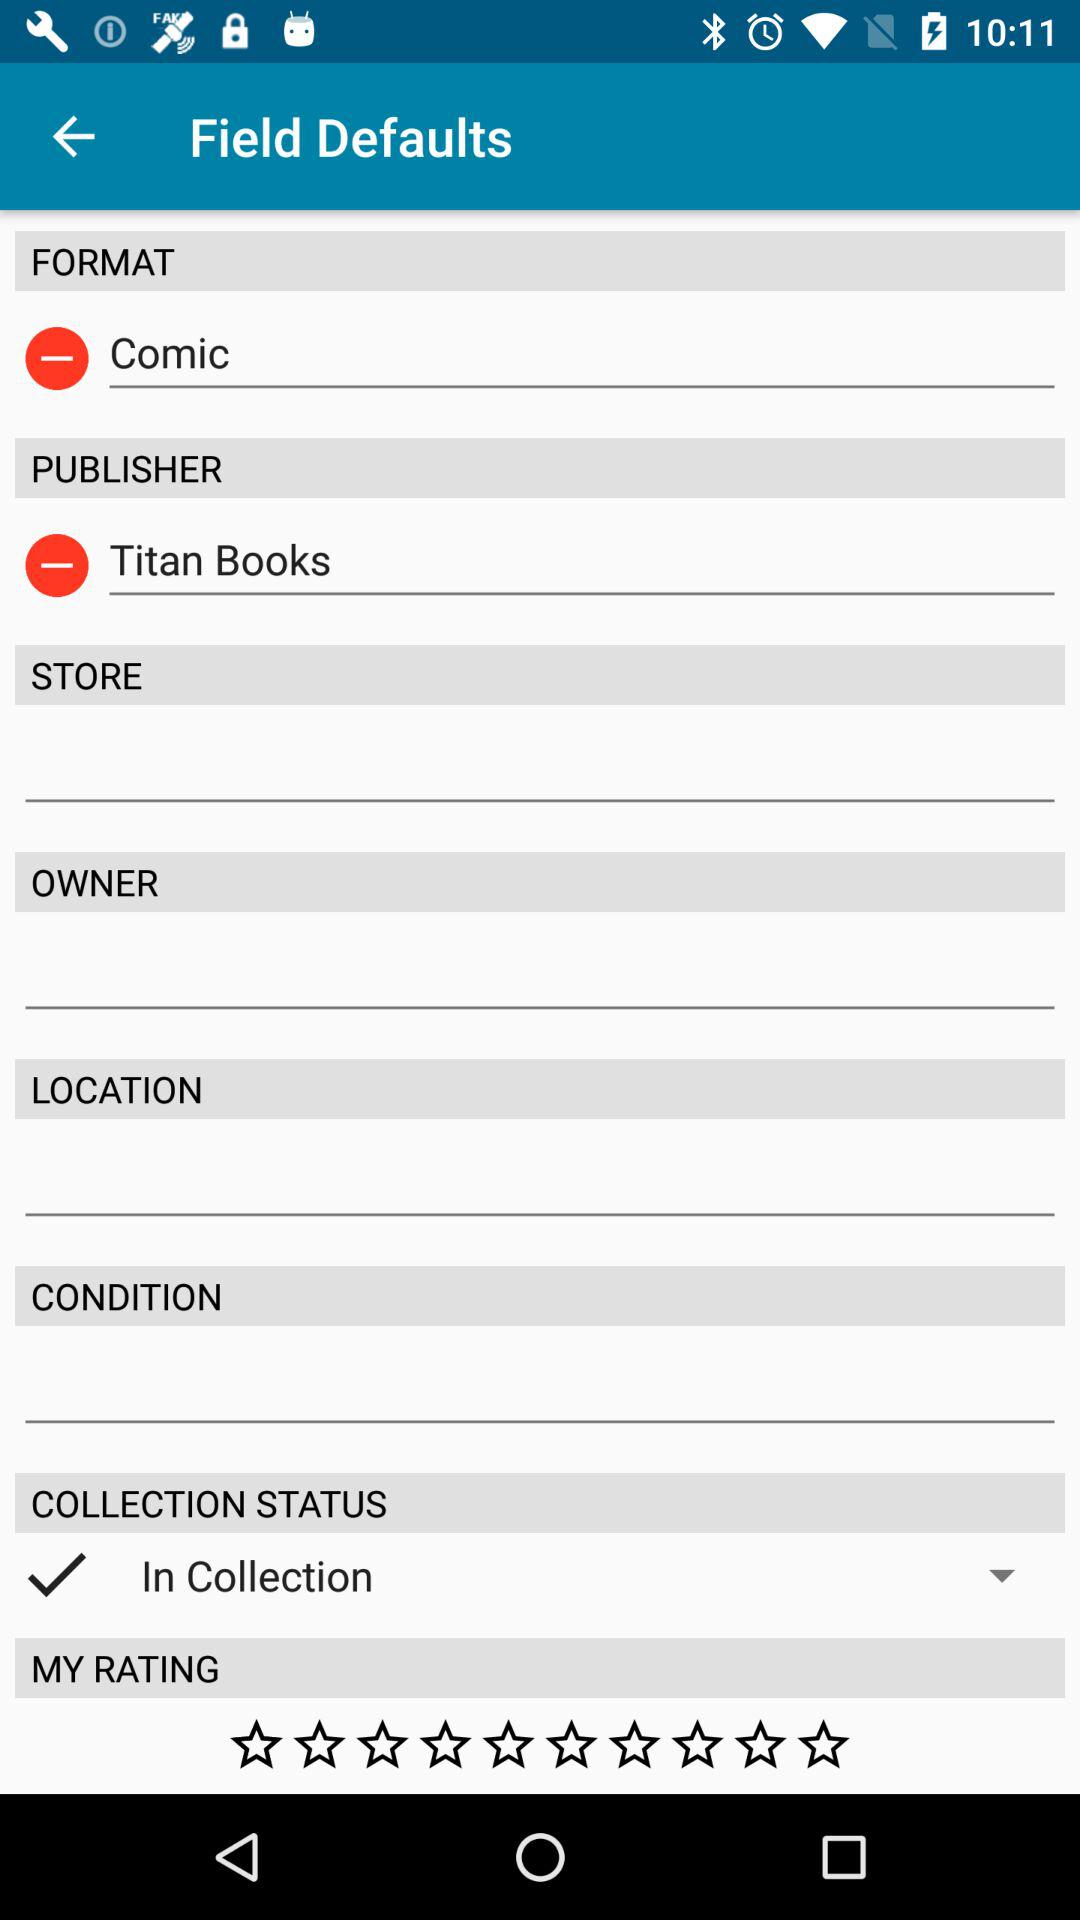Who is the publisher? The publisher is "Titan Books". 